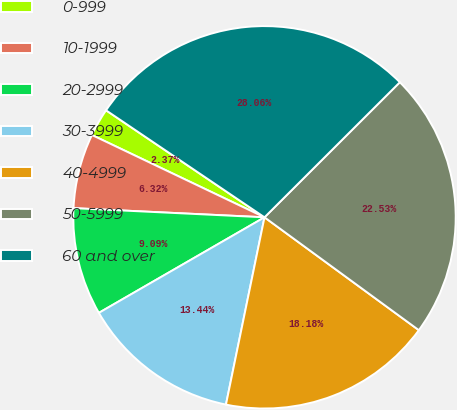<chart> <loc_0><loc_0><loc_500><loc_500><pie_chart><fcel>0-999<fcel>10-1999<fcel>20-2999<fcel>30-3999<fcel>40-4999<fcel>50-5999<fcel>60 and over<nl><fcel>2.37%<fcel>6.32%<fcel>9.09%<fcel>13.44%<fcel>18.18%<fcel>22.53%<fcel>28.06%<nl></chart> 